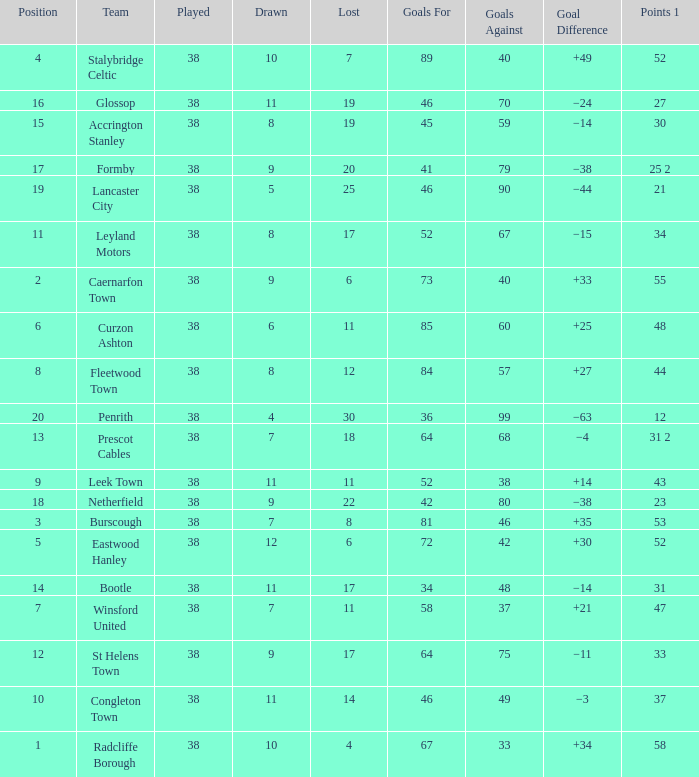WHAT IS THE SUM PLAYED WITH POINTS 1 OF 53, AND POSITION LARGER THAN 3? None. 